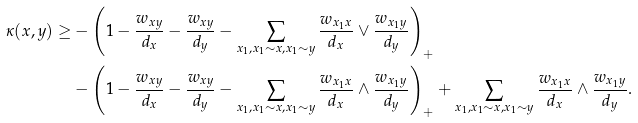Convert formula to latex. <formula><loc_0><loc_0><loc_500><loc_500>\kappa ( x , y ) \geq & - \left ( 1 - \frac { w _ { x y } } { d _ { x } } - \frac { w _ { x y } } { d _ { y } } - \sum _ { x _ { 1 } , x _ { 1 } \sim x , x _ { 1 } \sim y } \frac { w _ { x _ { 1 } x } } { d _ { x } } \vee \frac { w _ { x _ { 1 } y } } { d _ { y } } \right ) _ { + } \\ & - \left ( 1 - \frac { w _ { x y } } { d _ { x } } - \frac { w _ { x y } } { d _ { y } } - \sum _ { x _ { 1 } , x _ { 1 } \sim x , x _ { 1 } \sim y } \frac { w _ { x _ { 1 } x } } { d _ { x } } \wedge \frac { w _ { x _ { 1 } y } } { d _ { y } } \right ) _ { + } + \sum _ { x _ { 1 } , x _ { 1 } \sim x , x _ { 1 } \sim y } \frac { w _ { x _ { 1 } x } } { d _ { x } } \wedge \frac { w _ { x _ { 1 } y } } { d _ { y } } .</formula> 